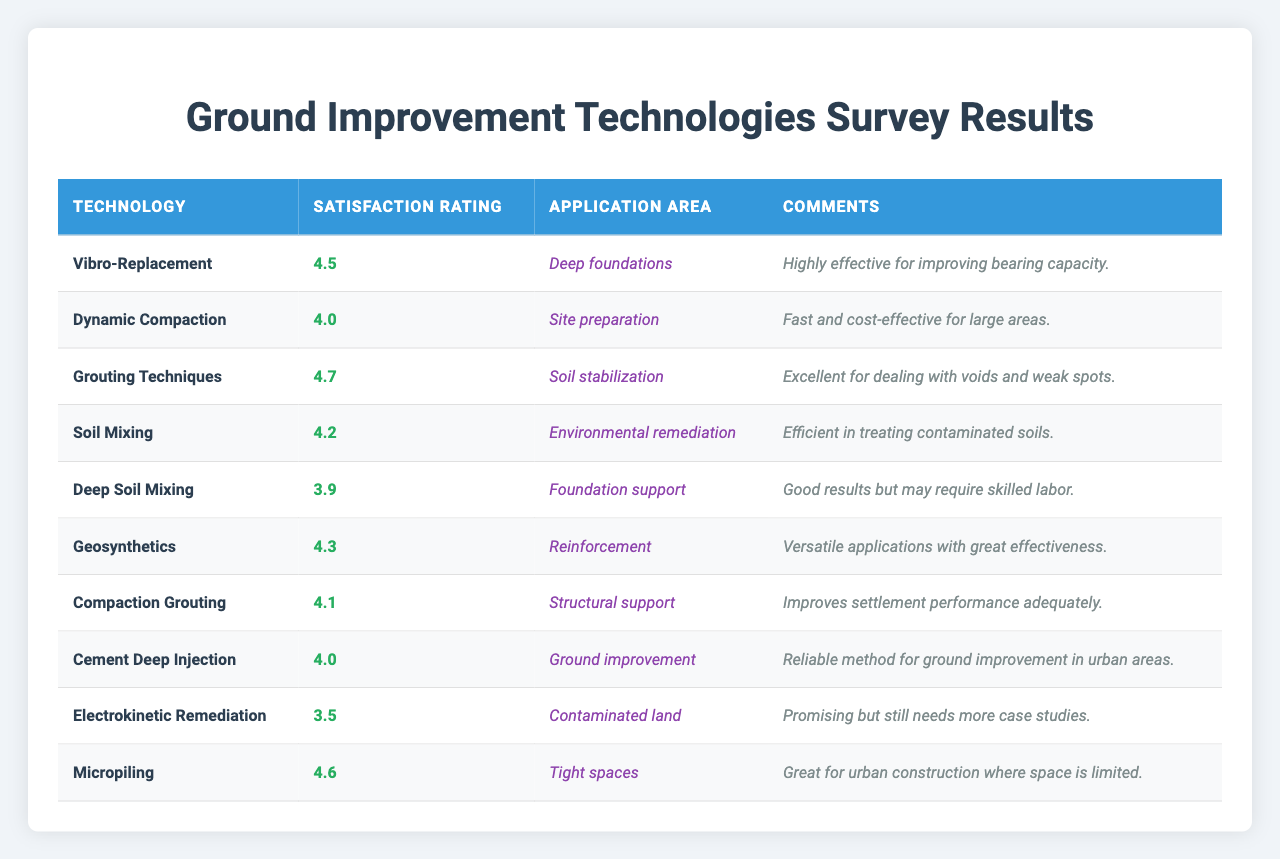What is the highest satisfaction rating among the technologies listed? The satisfaction ratings range from 3.5 to 4.7. By reviewing the ratings, I find that 4.7 is the highest rating, given for Grouting Techniques.
Answer: 4.7 Which technology has the application area of "Soil stabilization"? By scanning the table, I see that Grouting Techniques is the technology specifically mentioned for the application area of Soil stabilization.
Answer: Grouting Techniques What is the satisfaction rating of Deep Soil Mixing? Looking at the row for Deep Soil Mixing, the satisfaction rating listed is 3.9.
Answer: 3.9 How many technologies received a satisfaction rating of 4.0 or higher? The technologies with ratings of 4.0 or higher are Vibro-Replacement, Dynamic Compaction, Grouting Techniques, Soil Mixing, Geosynthetics, Compaction Grouting, Cement Deep Injection, and Micropiling. This totals to 8 technologies.
Answer: 8 What is the average satisfaction rating of all the technologies? The satisfaction ratings are as follows: 4.5, 4.0, 4.7, 4.2, 3.9, 4.3, 4.1, 4.0, 3.5, and 4.6. Adding these together gives 43.8. There are 10 ratings, so dividing 43.8 by 10 gives an average of 4.38.
Answer: 4.38 Does any technology have a satisfaction rating below 4.0? By checking the table, Electrokinetic Remediation has a satisfaction rating of 3.5, which is below 4.0.
Answer: Yes What is the technology with the lowest satisfaction rating and what is the application area? The lowest satisfaction rating is 3.5 for the technology Electrokinetic Remediation. The application area for this technology is Contaminated land.
Answer: Electrokinetic Remediation, Contaminated land Which technology is noted for being "Highly effective for improving bearing capacity"? The comments for Vibro-Replacement state that it is "Highly effective for improving bearing capacity."
Answer: Vibro-Replacement Which two technologies have application areas in urban settings? The technologies Cement Deep Injection and Micropiling both have application areas that are particularly focused on urban settings, as they deal with ground improvement in urban areas and construction in tight spaces, respectively.
Answer: Cement Deep Injection and Micropiling Is the satisfaction rating for Compaction Grouting higher than that of Dynamic Compaction? The satisfaction rating for Compaction Grouting is 4.1, while for Dynamic Compaction it is 4.0. Since 4.1 is greater than 4.0, the answer is yes.
Answer: Yes 